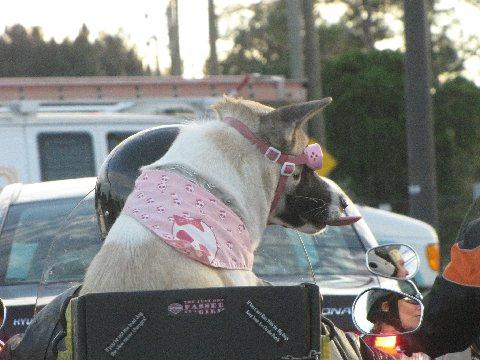Question: what is the dog on?
Choices:
A. A train.
B. A car seat.
C. A motorcycle.
D. A boat deck.
Answer with the letter. Answer: C Question: what is on the dog?
Choices:
A. A handkerchief.
B. A leash.
C. A collar.
D. A chain.
Answer with the letter. Answer: A 